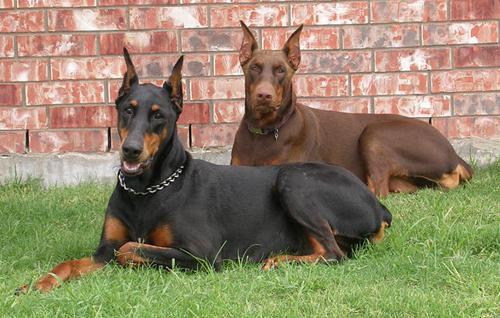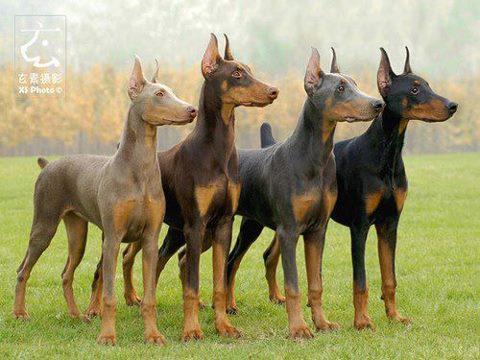The first image is the image on the left, the second image is the image on the right. Analyze the images presented: Is the assertion "At least one dog is lying down on the grass." valid? Answer yes or no. Yes. The first image is the image on the left, the second image is the image on the right. For the images shown, is this caption "Two images shown have one black and one brown doberman sitting together in the grass." true? Answer yes or no. No. 